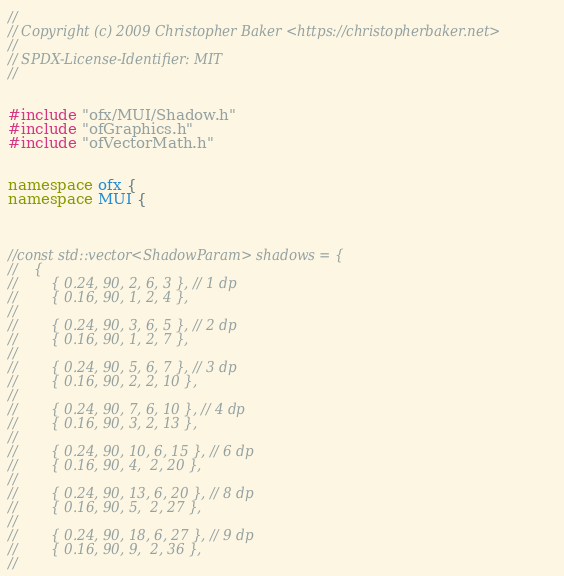<code> <loc_0><loc_0><loc_500><loc_500><_C++_>//
// Copyright (c) 2009 Christopher Baker <https://christopherbaker.net>
//
// SPDX-License-Identifier: MIT
//


#include "ofx/MUI/Shadow.h"
#include "ofGraphics.h"
#include "ofVectorMath.h"


namespace ofx {
namespace MUI {



//const std::vector<ShadowParam> shadows = {
//    {
//        { 0.24, 90, 2, 6, 3 }, // 1 dp
//        { 0.16, 90, 1, 2, 4 },
//
//        { 0.24, 90, 3, 6, 5 }, // 2 dp
//        { 0.16, 90, 1, 2, 7 },
//
//        { 0.24, 90, 5, 6, 7 }, // 3 dp
//        { 0.16, 90, 2, 2, 10 },
//
//        { 0.24, 90, 7, 6, 10 }, // 4 dp
//        { 0.16, 90, 3, 2, 13 },
//
//        { 0.24, 90, 10, 6, 15 }, // 6 dp
//        { 0.16, 90, 4,  2, 20 },
//
//        { 0.24, 90, 13, 6, 20 }, // 8 dp
//        { 0.16, 90, 5,  2, 27 },
//
//        { 0.24, 90, 18, 6, 27 }, // 9 dp
//        { 0.16, 90, 9,  2, 36 },
//</code> 